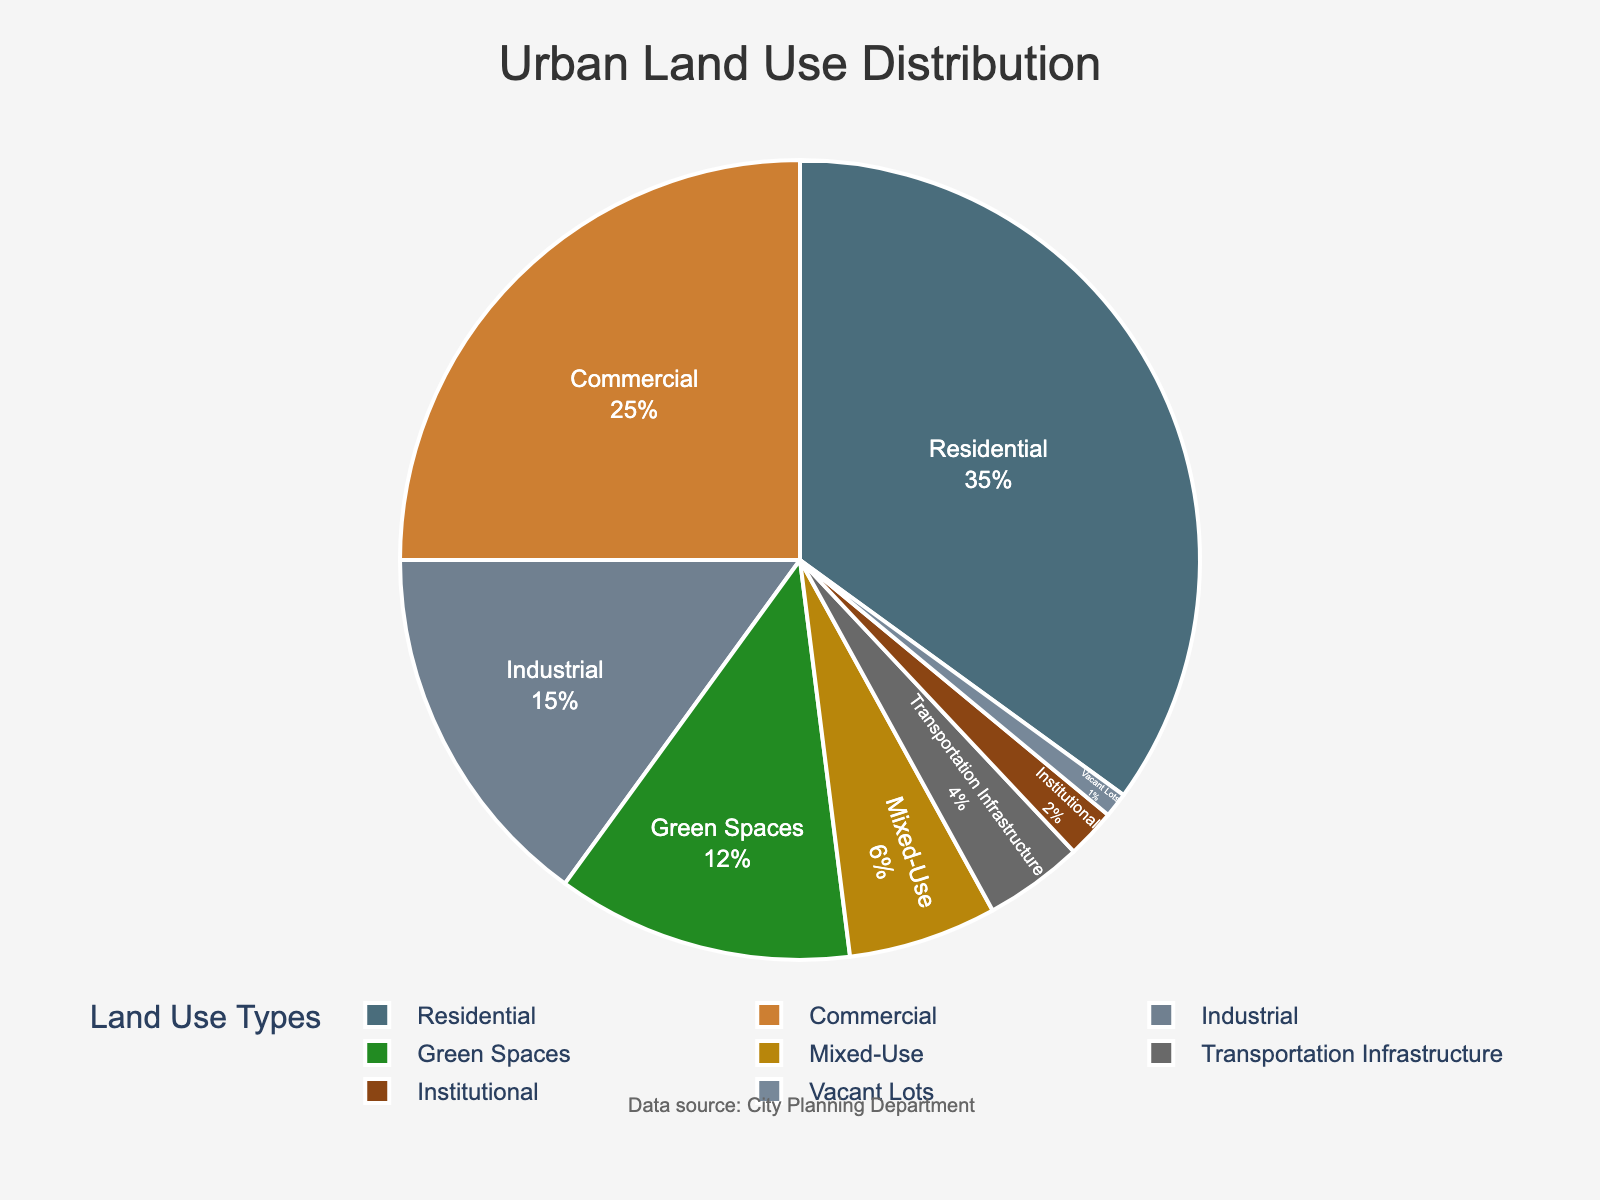What is the second most prevalent land use type in the city? The figure shows the percentage of each land use type. By looking at the values, Residential (35%) is the highest, followed by Commercial (25%).
Answer: Commercial What is the combined percentage of Residential and Green Spaces? Add the percentages of Residential (35%) and Green Spaces (12%): \(35 + 12 = 47\).
Answer: 47% Which land use type accounts for the smallest percentage and what is its value? By examining the smaller segments of the pie chart, Vacant Lots is the smallest at 1%.
Answer: Vacant Lots, 1% How does the percentage of Mixed-Use land compare to that of Transportation Infrastructure? Compare their values: Mixed-Use is 6% and Transportation Infrastructure is 4%. Mixed-Use is greater.
Answer: Mixed-Use is greater If you combine Commercial, Industrial, and Institutional land, what percentage of the city's land use does it represent? Add the percentages: Commercial (25%) + Industrial (15%) + Institutional (2%): \(25 + 15 + 2 = 42\).
Answer: 42% What color represents Green Spaces in the pie chart? Refer to the color from the pie chart corresponding to “Green Spaces,” which is visually identifiable as green.
Answer: Green Among Residential, Commercial, and Industrial land uses, which has the smallest percentage? By comparing their percentages, Industrial (15%) is less than Residential (35%) and Commercial (25%).
Answer: Industrial What is the percentage difference between Residential and Institutional land use types? Subtract the smaller percentage from the larger one: \(35 - 2 = 33\).
Answer: 33% What is the total percentage of land used for non-residential purposes? Subtract the percentage of Residential from 100%: \(100 - 35 = 65\).
Answer: 65% Which land use type has nearly half the percentage of Residential land? Industrial (15%) is nearly half of Residential (35%). \(35/2 = 17.5\), and 15% is close.
Answer: Industrial 